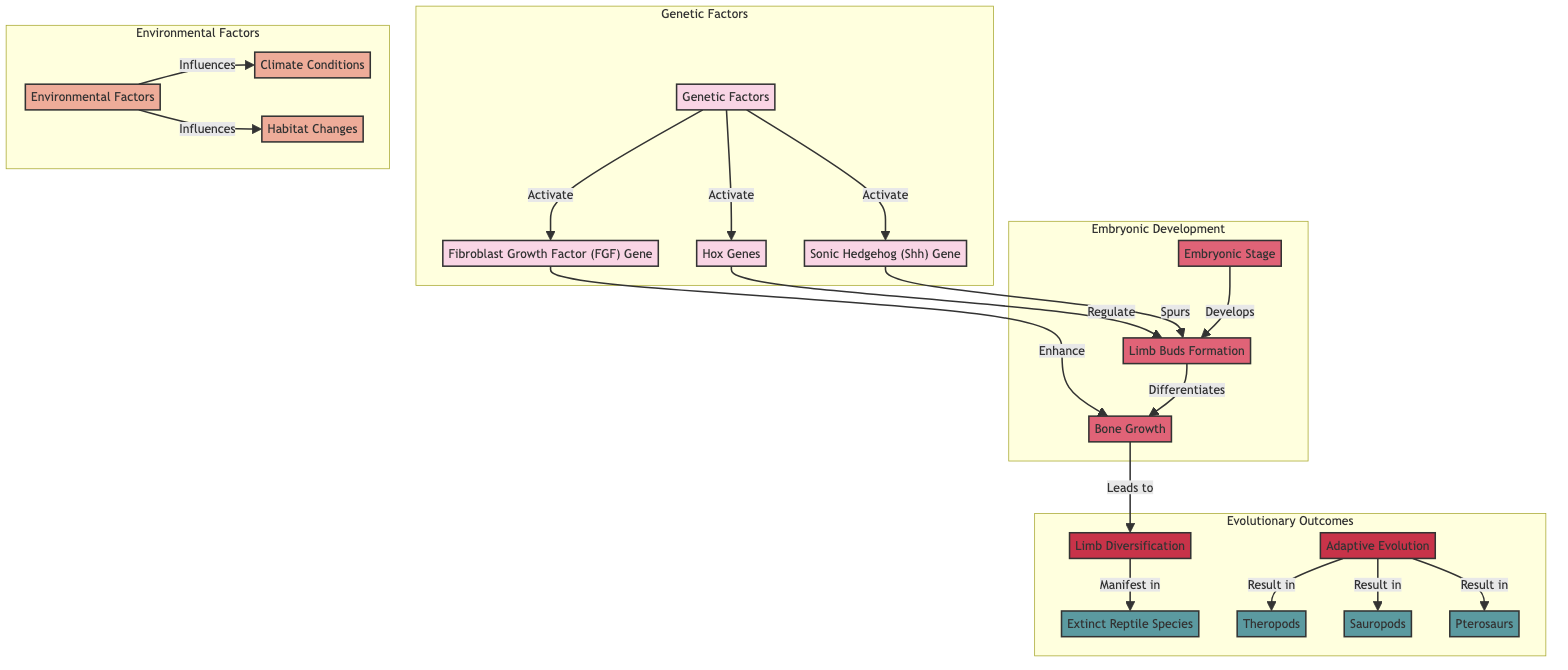What factors influence limb morphogenesis in prehistoric reptiles? The diagram indicates that limb morphogenesis is influenced by two main categories: genetic factors and environmental factors. These are represented by the nodes "Genetic Factors" and "Environmental Factors" in the diagram.
Answer: Genetic and Environmental Factors How do Hox genes affect limb bud formation? According to the diagram, Hox genes are activated by genetic factors and are represented here as regulating limb buds, which means they play a direct role in the formation of limb buds.
Answer: Regulate How many species are represented in the evolutionary outcomes section of the diagram? The diagram shows a total of four species in the evolutionary outcomes section: theropods, sauropods, pterosaurs, and extinct reptiles. Counting all these nodes gives us four distinct species.
Answer: Four What role does the Sonic Hedgehog gene play in embryonic development? The diagram illustrates that the Sonic Hedgehog (Shh) gene spurs the formation of limb buds, showing its essential role in the early stages of limb development in embryos.
Answer: Spurs What is the outcome of adaptive evolution according to the diagram? The diagram indicates that adaptive evolution leads to the emergence of theropods, sauropods, and pterosaurs, each resulting from different adaptations that occurred over time.
Answer: Theropods, Sauropods, Pterosaurs How does climate condition influence limb development? The environmental factors section of the diagram states that climate conditions influence limb development indirectly by affecting other environmental factors such as habitat changes, indicating a cascading effect in the development process.
Answer: Influences Which gene enhances bone growth during limb development? The diagram clearly shows that the Fibroblast Growth Factor (FGF) gene enhances bone growth. This relationship highlights the FGF gene's critical function during the limb growth phase.
Answer: Enhance What is the relationship between limb buds and bone growth? The diagram demonstrates that limb buds develop into bone growth, indicating that limb buds are a precursor state that differentiates into bones during the embryonic development process.
Answer: Differentiates What does the limb diversification lead to in extinct reptiles? According to the diagram, limb diversification manifests in extinct reptiles, meaning that the variations and adaptations of limbs seen in these species are a direct result of their evolutionary development pathways.
Answer: Manifest in 